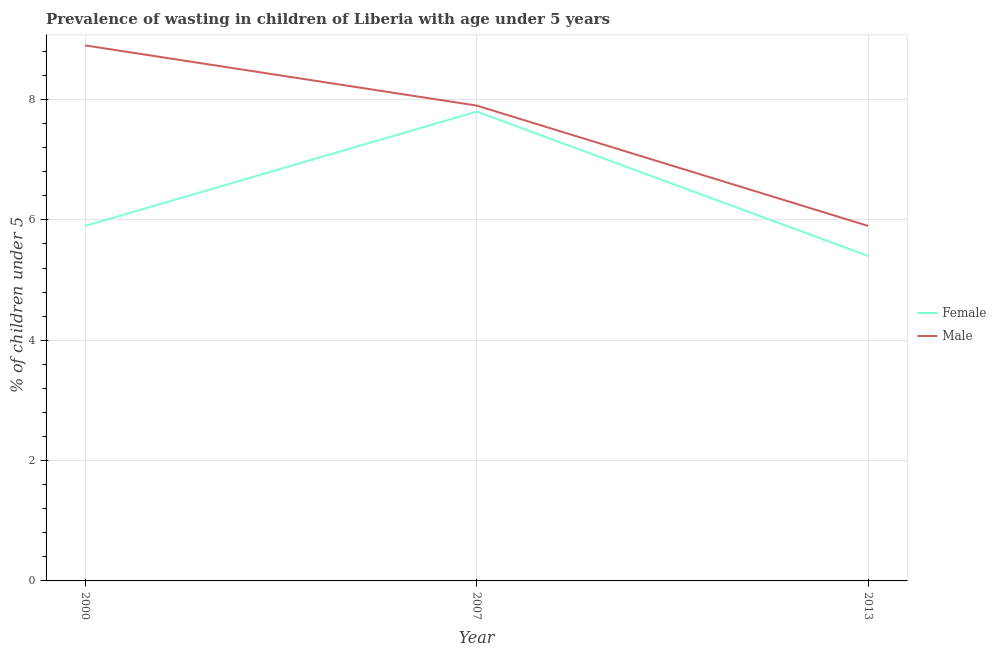How many different coloured lines are there?
Provide a short and direct response. 2. Does the line corresponding to percentage of undernourished female children intersect with the line corresponding to percentage of undernourished male children?
Ensure brevity in your answer.  No. What is the percentage of undernourished female children in 2013?
Keep it short and to the point. 5.4. Across all years, what is the maximum percentage of undernourished male children?
Provide a short and direct response. 8.9. Across all years, what is the minimum percentage of undernourished male children?
Ensure brevity in your answer.  5.9. In which year was the percentage of undernourished female children maximum?
Provide a succinct answer. 2007. In which year was the percentage of undernourished female children minimum?
Make the answer very short. 2013. What is the total percentage of undernourished female children in the graph?
Offer a very short reply. 19.1. What is the difference between the percentage of undernourished male children in 2000 and that in 2007?
Your response must be concise. 1. What is the difference between the percentage of undernourished male children in 2013 and the percentage of undernourished female children in 2007?
Offer a terse response. -1.9. What is the average percentage of undernourished male children per year?
Offer a terse response. 7.57. In the year 2007, what is the difference between the percentage of undernourished female children and percentage of undernourished male children?
Give a very brief answer. -0.1. In how many years, is the percentage of undernourished female children greater than 5.2 %?
Your answer should be compact. 3. What is the ratio of the percentage of undernourished female children in 2007 to that in 2013?
Provide a short and direct response. 1.44. Is the percentage of undernourished female children in 2000 less than that in 2013?
Provide a short and direct response. No. Is the difference between the percentage of undernourished male children in 2007 and 2013 greater than the difference between the percentage of undernourished female children in 2007 and 2013?
Ensure brevity in your answer.  No. What is the difference between the highest and the second highest percentage of undernourished male children?
Offer a very short reply. 1. What is the difference between the highest and the lowest percentage of undernourished male children?
Offer a very short reply. 3. In how many years, is the percentage of undernourished female children greater than the average percentage of undernourished female children taken over all years?
Your response must be concise. 1. Is the percentage of undernourished female children strictly less than the percentage of undernourished male children over the years?
Your answer should be compact. Yes. What is the difference between two consecutive major ticks on the Y-axis?
Provide a succinct answer. 2. Does the graph contain grids?
Provide a succinct answer. Yes. What is the title of the graph?
Give a very brief answer. Prevalence of wasting in children of Liberia with age under 5 years. What is the label or title of the X-axis?
Offer a very short reply. Year. What is the label or title of the Y-axis?
Your answer should be compact.  % of children under 5. What is the  % of children under 5 of Female in 2000?
Your answer should be very brief. 5.9. What is the  % of children under 5 of Male in 2000?
Ensure brevity in your answer.  8.9. What is the  % of children under 5 in Female in 2007?
Your response must be concise. 7.8. What is the  % of children under 5 in Male in 2007?
Your answer should be very brief. 7.9. What is the  % of children under 5 of Female in 2013?
Your answer should be compact. 5.4. What is the  % of children under 5 of Male in 2013?
Keep it short and to the point. 5.9. Across all years, what is the maximum  % of children under 5 in Female?
Make the answer very short. 7.8. Across all years, what is the maximum  % of children under 5 in Male?
Ensure brevity in your answer.  8.9. Across all years, what is the minimum  % of children under 5 in Female?
Provide a short and direct response. 5.4. Across all years, what is the minimum  % of children under 5 in Male?
Give a very brief answer. 5.9. What is the total  % of children under 5 of Male in the graph?
Your answer should be compact. 22.7. What is the difference between the  % of children under 5 of Female in 2000 and that in 2007?
Make the answer very short. -1.9. What is the difference between the  % of children under 5 in Female in 2007 and that in 2013?
Keep it short and to the point. 2.4. What is the difference between the  % of children under 5 of Female in 2007 and the  % of children under 5 of Male in 2013?
Provide a short and direct response. 1.9. What is the average  % of children under 5 of Female per year?
Give a very brief answer. 6.37. What is the average  % of children under 5 in Male per year?
Offer a very short reply. 7.57. In the year 2007, what is the difference between the  % of children under 5 of Female and  % of children under 5 of Male?
Your answer should be very brief. -0.1. What is the ratio of the  % of children under 5 in Female in 2000 to that in 2007?
Your answer should be compact. 0.76. What is the ratio of the  % of children under 5 of Male in 2000 to that in 2007?
Give a very brief answer. 1.13. What is the ratio of the  % of children under 5 in Female in 2000 to that in 2013?
Your answer should be very brief. 1.09. What is the ratio of the  % of children under 5 in Male in 2000 to that in 2013?
Your answer should be very brief. 1.51. What is the ratio of the  % of children under 5 in Female in 2007 to that in 2013?
Your answer should be very brief. 1.44. What is the ratio of the  % of children under 5 in Male in 2007 to that in 2013?
Provide a short and direct response. 1.34. What is the difference between the highest and the second highest  % of children under 5 in Female?
Your answer should be compact. 1.9. What is the difference between the highest and the lowest  % of children under 5 of Female?
Keep it short and to the point. 2.4. 